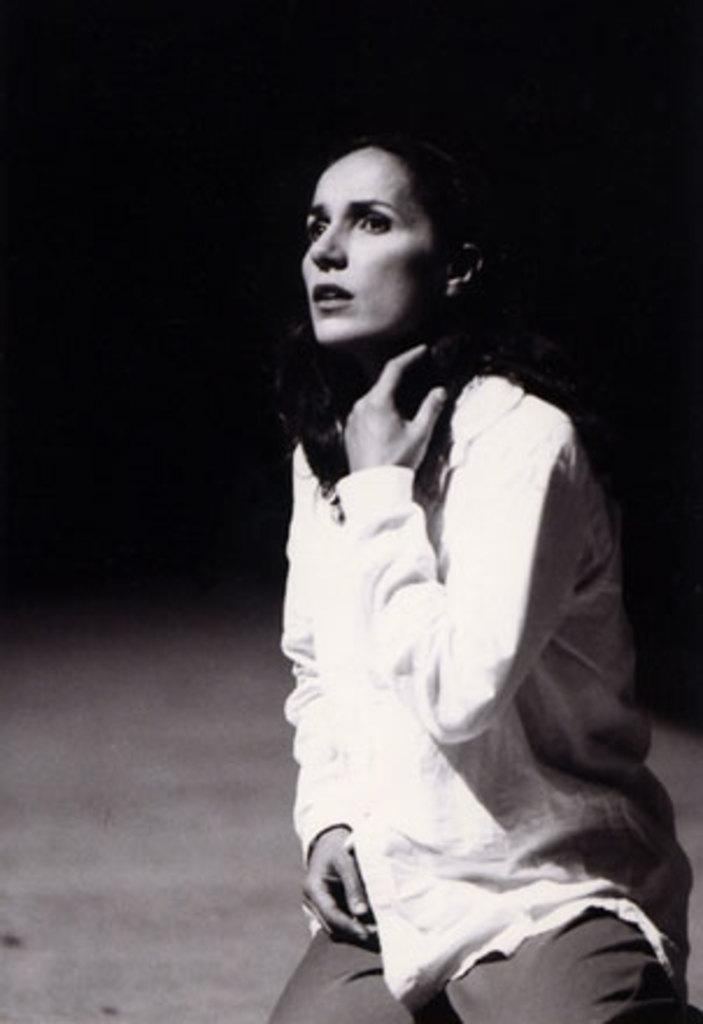How would you summarize this image in a sentence or two? In the foreground we can see a woman. The background is blurred. 